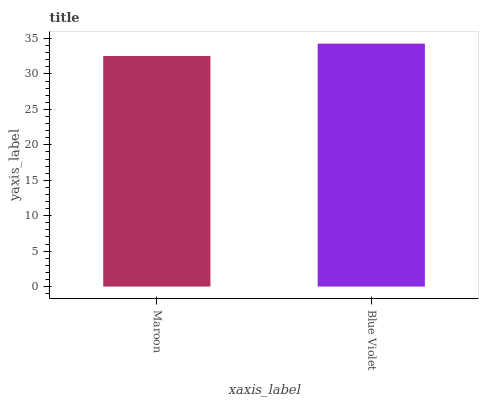Is Maroon the minimum?
Answer yes or no. Yes. Is Blue Violet the maximum?
Answer yes or no. Yes. Is Blue Violet the minimum?
Answer yes or no. No. Is Blue Violet greater than Maroon?
Answer yes or no. Yes. Is Maroon less than Blue Violet?
Answer yes or no. Yes. Is Maroon greater than Blue Violet?
Answer yes or no. No. Is Blue Violet less than Maroon?
Answer yes or no. No. Is Blue Violet the high median?
Answer yes or no. Yes. Is Maroon the low median?
Answer yes or no. Yes. Is Maroon the high median?
Answer yes or no. No. Is Blue Violet the low median?
Answer yes or no. No. 